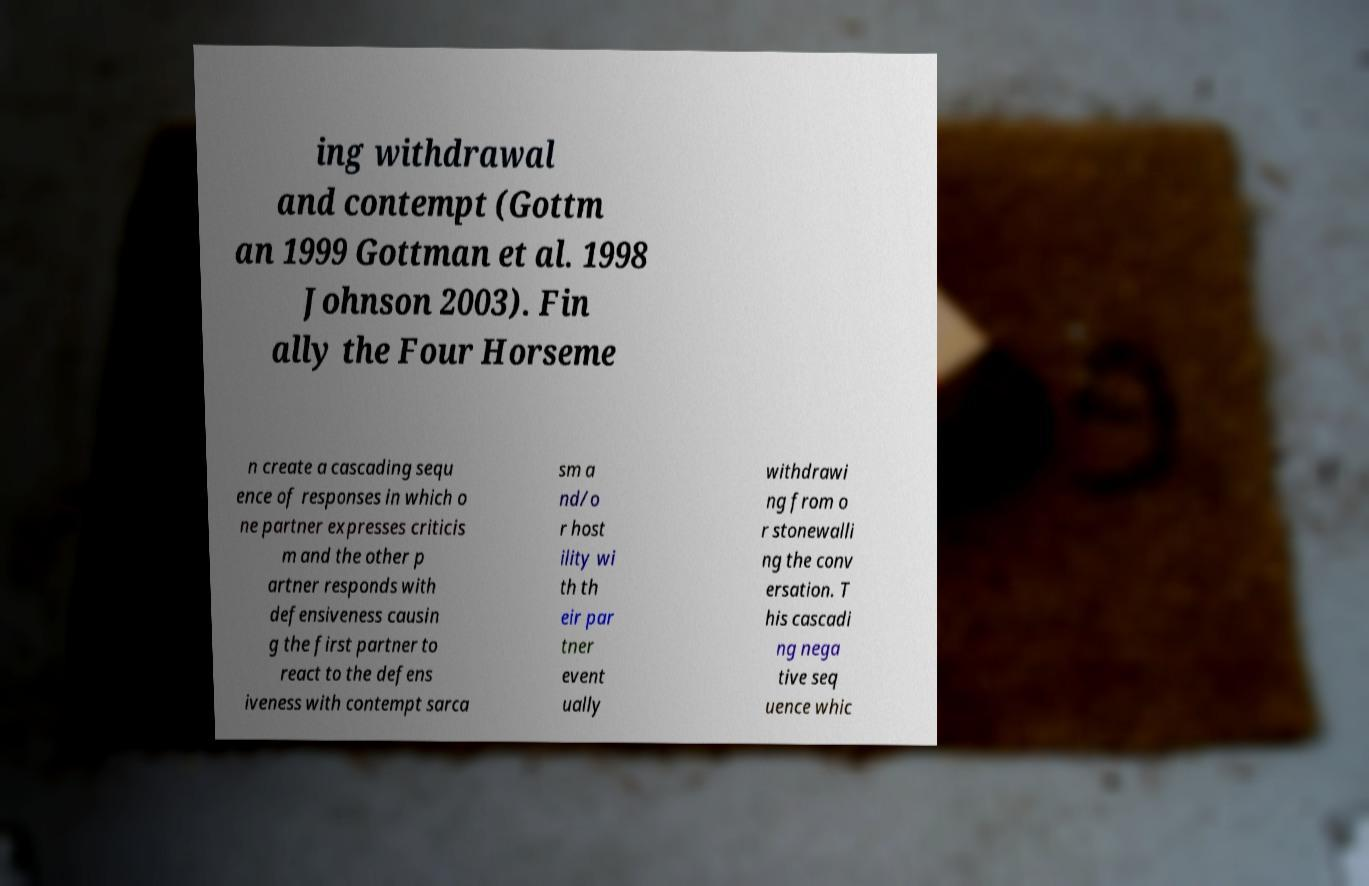Can you read and provide the text displayed in the image?This photo seems to have some interesting text. Can you extract and type it out for me? ing withdrawal and contempt (Gottm an 1999 Gottman et al. 1998 Johnson 2003). Fin ally the Four Horseme n create a cascading sequ ence of responses in which o ne partner expresses criticis m and the other p artner responds with defensiveness causin g the first partner to react to the defens iveness with contempt sarca sm a nd/o r host ility wi th th eir par tner event ually withdrawi ng from o r stonewalli ng the conv ersation. T his cascadi ng nega tive seq uence whic 